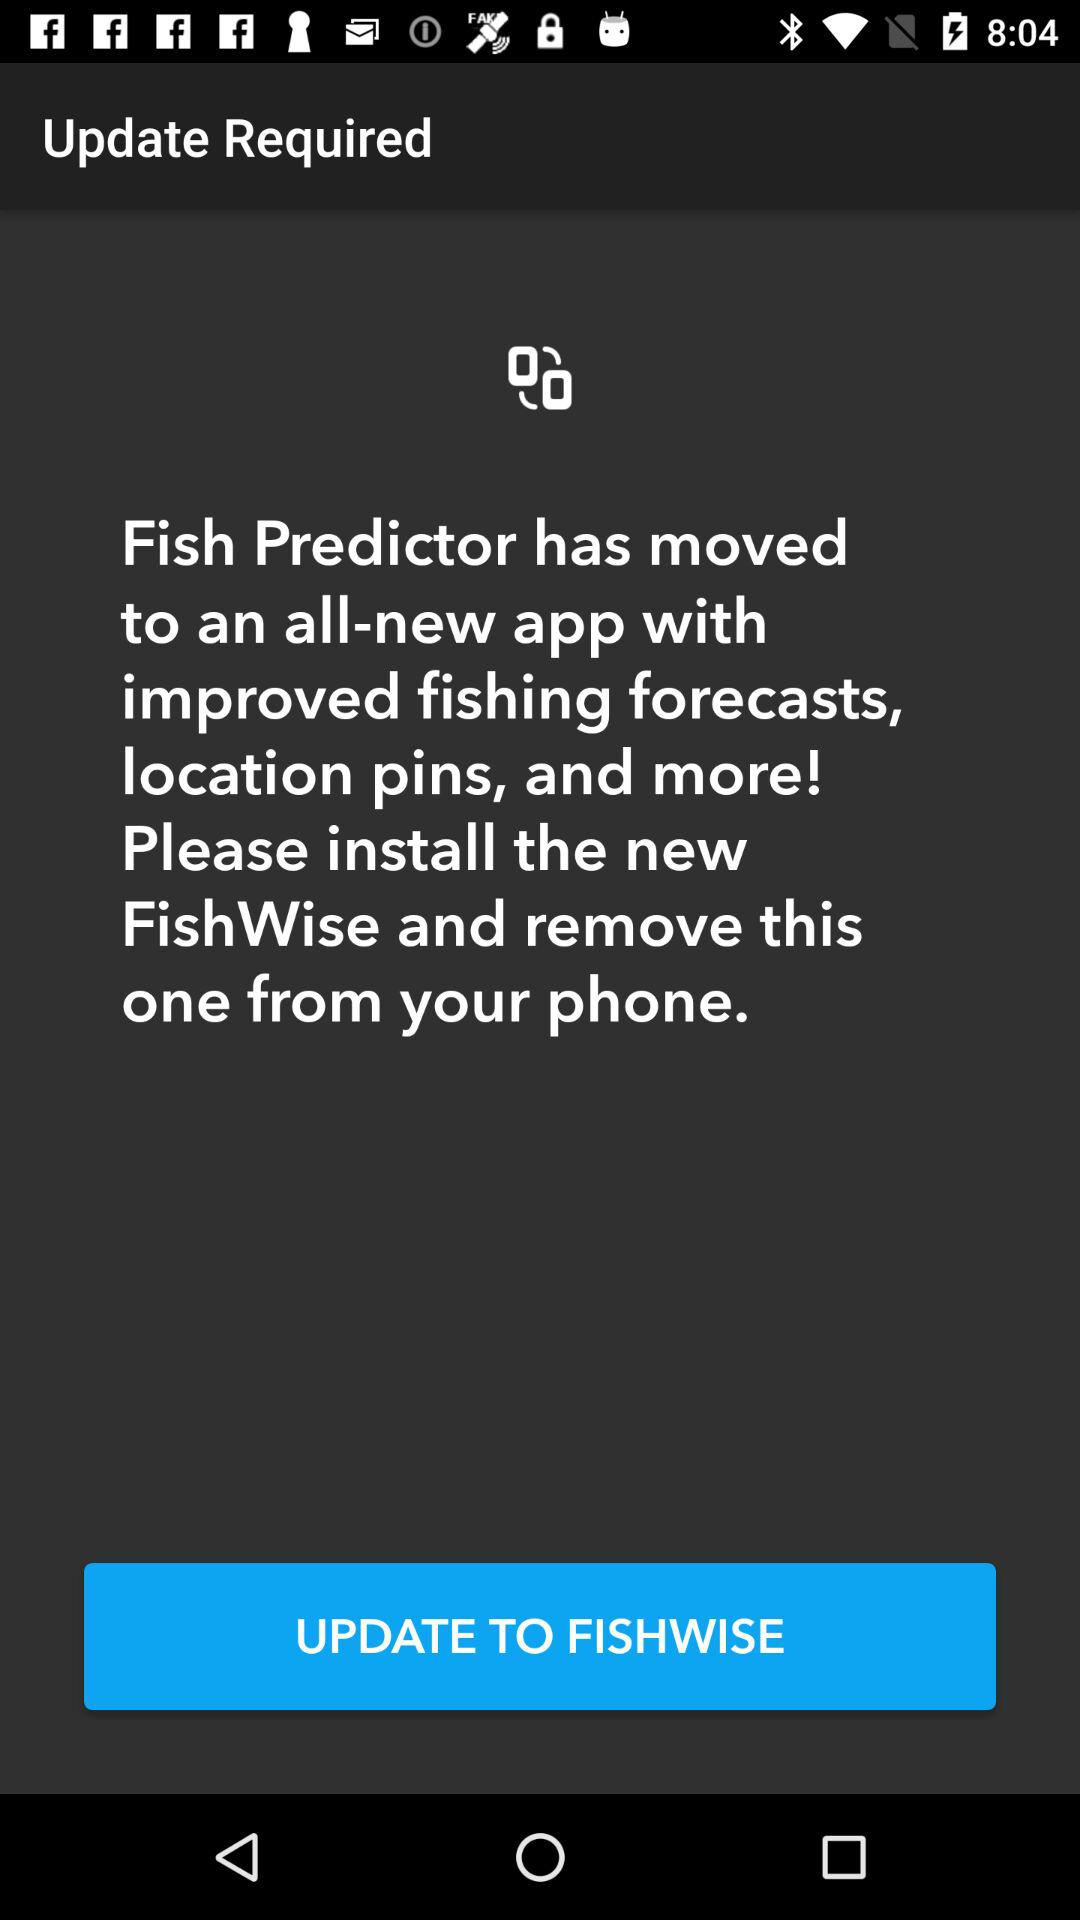What is the name of the application? The name of the application is "FISHWISE". 